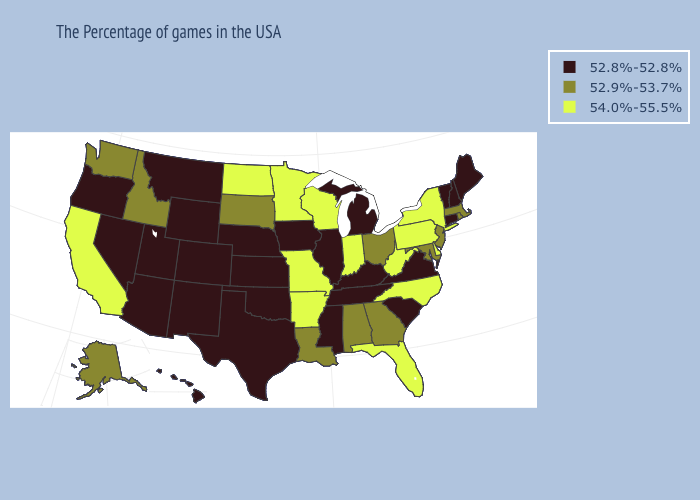How many symbols are there in the legend?
Be succinct. 3. Which states hav the highest value in the West?
Quick response, please. California. Does West Virginia have a higher value than Arkansas?
Write a very short answer. No. Name the states that have a value in the range 52.8%-52.8%?
Give a very brief answer. Maine, New Hampshire, Vermont, Connecticut, Virginia, South Carolina, Michigan, Kentucky, Tennessee, Illinois, Mississippi, Iowa, Kansas, Nebraska, Oklahoma, Texas, Wyoming, Colorado, New Mexico, Utah, Montana, Arizona, Nevada, Oregon, Hawaii. Among the states that border Arkansas , does Missouri have the lowest value?
Concise answer only. No. What is the value of Iowa?
Concise answer only. 52.8%-52.8%. What is the lowest value in states that border Illinois?
Be succinct. 52.8%-52.8%. Which states have the lowest value in the USA?
Keep it brief. Maine, New Hampshire, Vermont, Connecticut, Virginia, South Carolina, Michigan, Kentucky, Tennessee, Illinois, Mississippi, Iowa, Kansas, Nebraska, Oklahoma, Texas, Wyoming, Colorado, New Mexico, Utah, Montana, Arizona, Nevada, Oregon, Hawaii. Does California have the highest value in the West?
Be succinct. Yes. Name the states that have a value in the range 52.9%-53.7%?
Be succinct. Massachusetts, Rhode Island, New Jersey, Maryland, Ohio, Georgia, Alabama, Louisiana, South Dakota, Idaho, Washington, Alaska. Does Michigan have the highest value in the MidWest?
Quick response, please. No. Name the states that have a value in the range 52.8%-52.8%?
Keep it brief. Maine, New Hampshire, Vermont, Connecticut, Virginia, South Carolina, Michigan, Kentucky, Tennessee, Illinois, Mississippi, Iowa, Kansas, Nebraska, Oklahoma, Texas, Wyoming, Colorado, New Mexico, Utah, Montana, Arizona, Nevada, Oregon, Hawaii. What is the value of Michigan?
Quick response, please. 52.8%-52.8%. Which states have the highest value in the USA?
Concise answer only. New York, Delaware, Pennsylvania, North Carolina, West Virginia, Florida, Indiana, Wisconsin, Missouri, Arkansas, Minnesota, North Dakota, California. What is the lowest value in the USA?
Answer briefly. 52.8%-52.8%. 